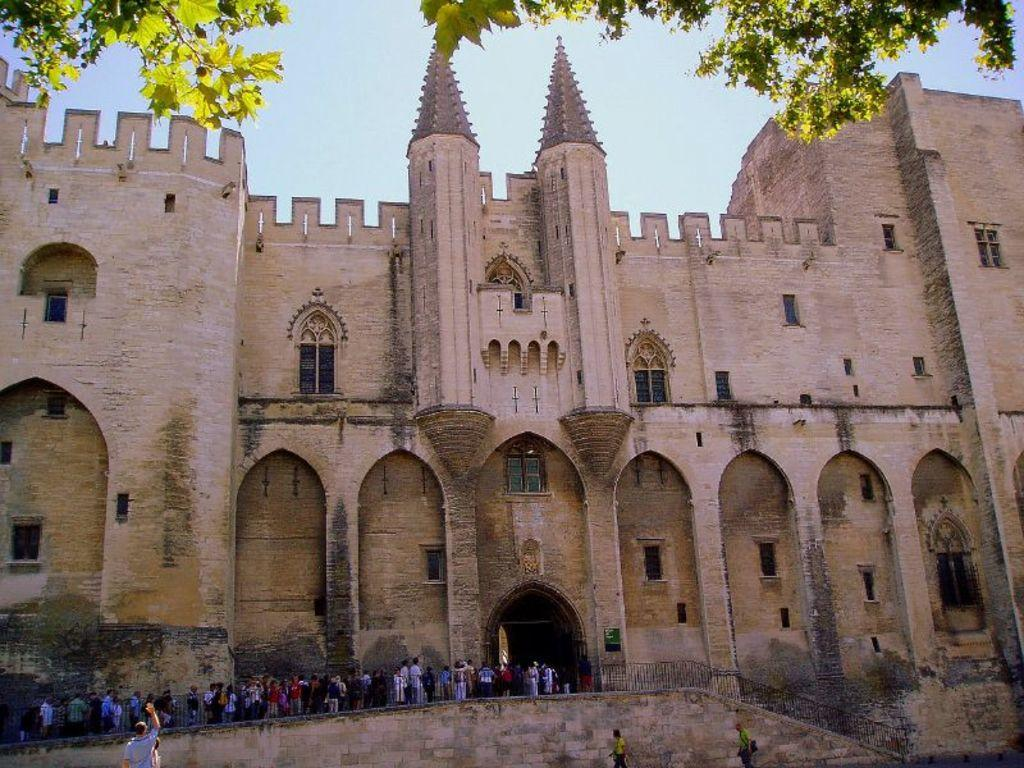What type of structure is present in the image? There is a building in the image. What is the color of the building? The building is brown in color. What are the people doing in the image? The people are standing inside a railing. What is the color of the railing? The railing is black in color. What can be seen in the background of the image? There are trees and the sky visible in the background of the image. Can you tell me the value of the airplane flying in the fog in the image? There is no airplane or fog present in the image, so it is not possible to determine the value of an airplane in this context. 